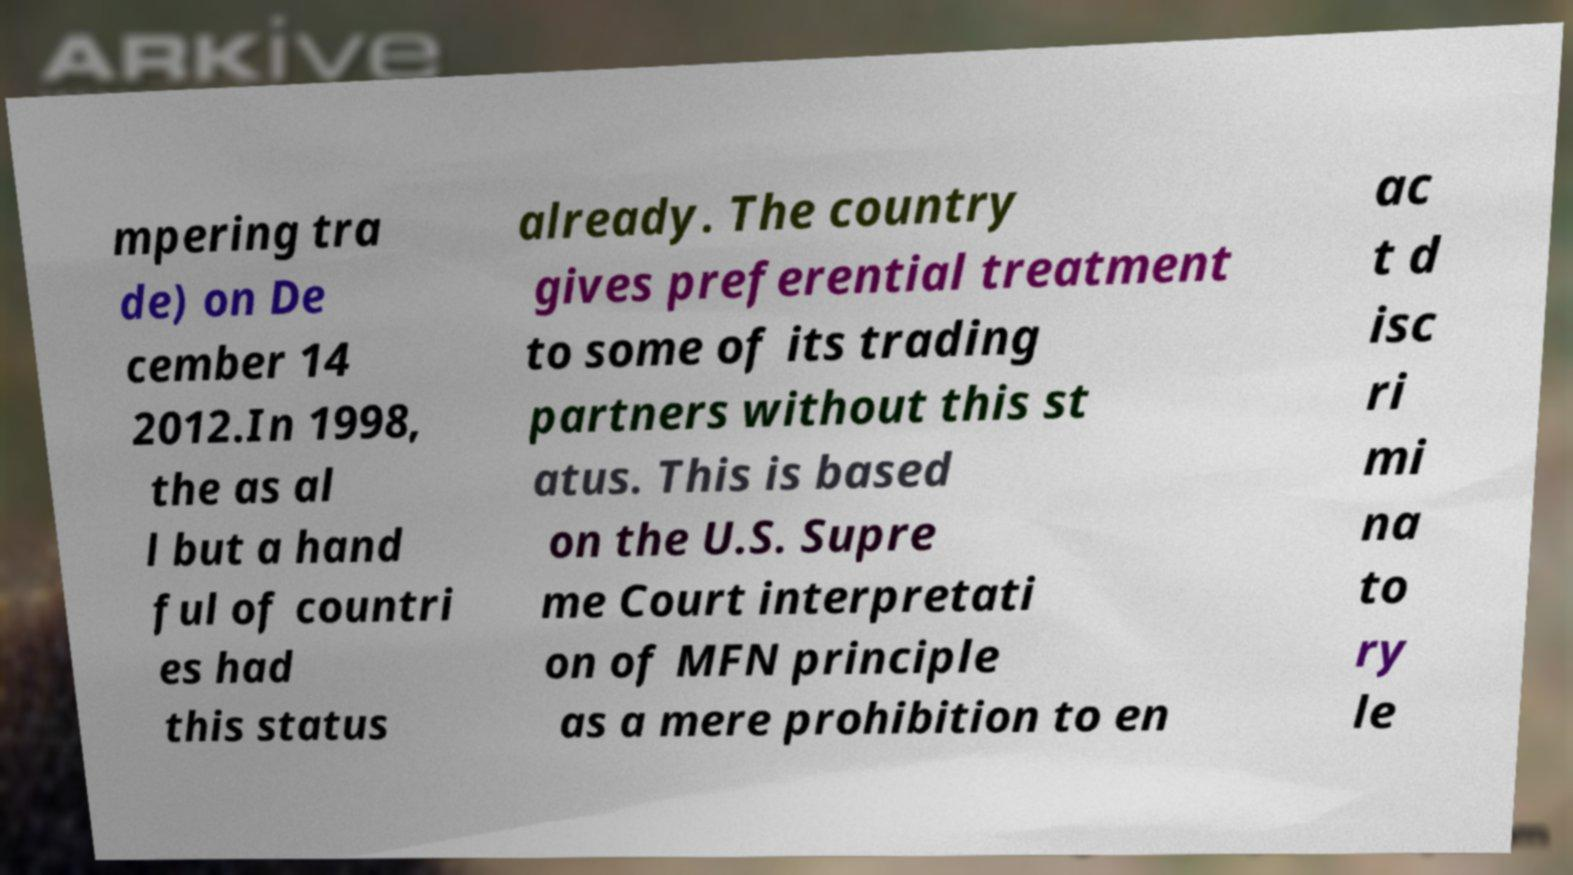Please identify and transcribe the text found in this image. mpering tra de) on De cember 14 2012.In 1998, the as al l but a hand ful of countri es had this status already. The country gives preferential treatment to some of its trading partners without this st atus. This is based on the U.S. Supre me Court interpretati on of MFN principle as a mere prohibition to en ac t d isc ri mi na to ry le 